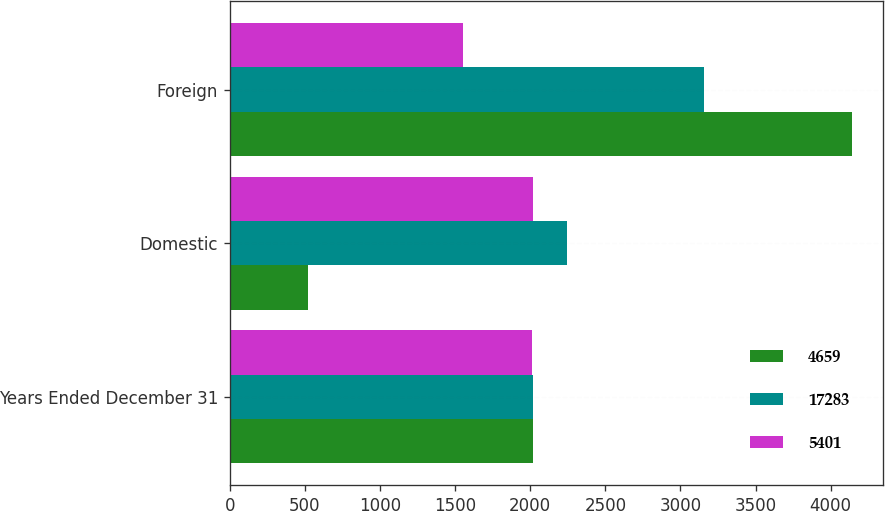<chart> <loc_0><loc_0><loc_500><loc_500><stacked_bar_chart><ecel><fcel>Years Ended December 31<fcel>Domestic<fcel>Foreign<nl><fcel>4659<fcel>2016<fcel>518<fcel>4141<nl><fcel>17283<fcel>2015<fcel>2247<fcel>3154<nl><fcel>5401<fcel>2014<fcel>2015.5<fcel>1553<nl></chart> 